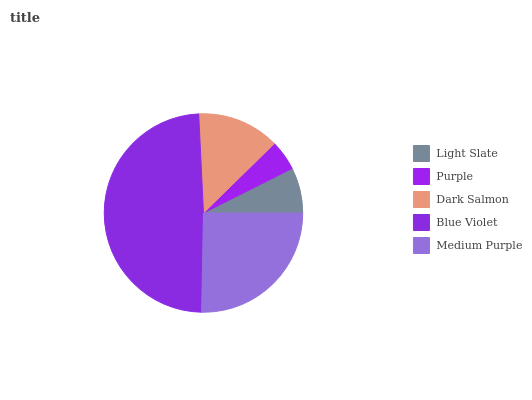Is Purple the minimum?
Answer yes or no. Yes. Is Blue Violet the maximum?
Answer yes or no. Yes. Is Dark Salmon the minimum?
Answer yes or no. No. Is Dark Salmon the maximum?
Answer yes or no. No. Is Dark Salmon greater than Purple?
Answer yes or no. Yes. Is Purple less than Dark Salmon?
Answer yes or no. Yes. Is Purple greater than Dark Salmon?
Answer yes or no. No. Is Dark Salmon less than Purple?
Answer yes or no. No. Is Dark Salmon the high median?
Answer yes or no. Yes. Is Dark Salmon the low median?
Answer yes or no. Yes. Is Blue Violet the high median?
Answer yes or no. No. Is Purple the low median?
Answer yes or no. No. 